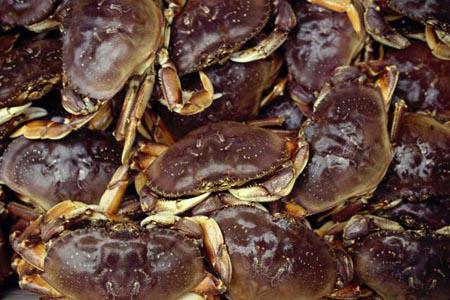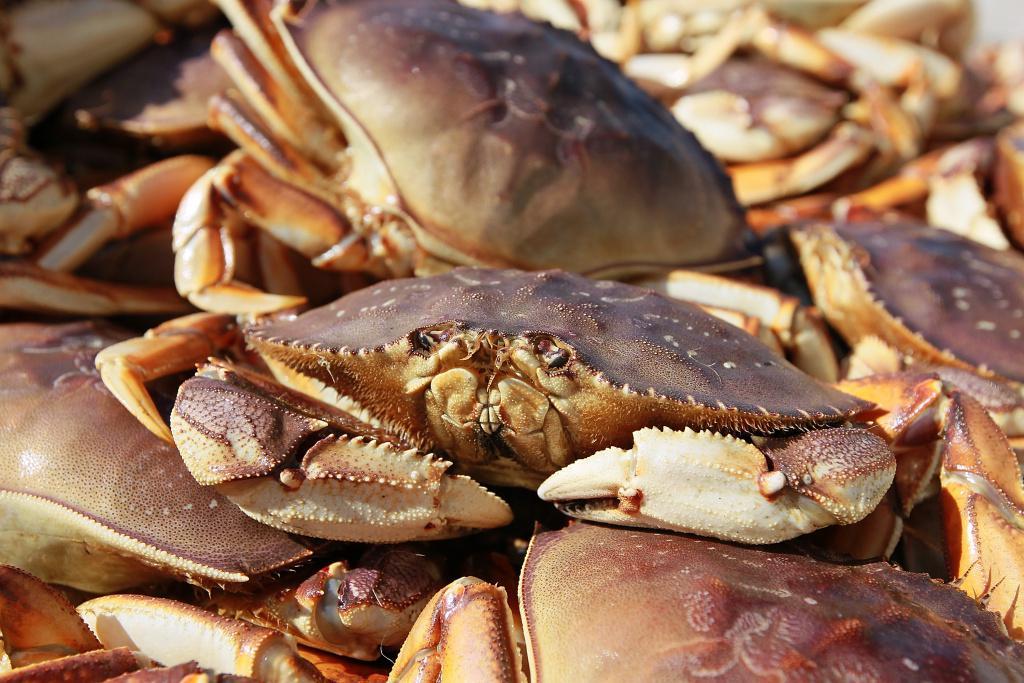The first image is the image on the left, the second image is the image on the right. For the images shown, is this caption "there are 3 crabs stacked on top of each other, all three are upside down" true? Answer yes or no. No. The first image is the image on the left, the second image is the image on the right. Evaluate the accuracy of this statement regarding the images: "There are three crabs stacked on top of each other.". Is it true? Answer yes or no. No. 